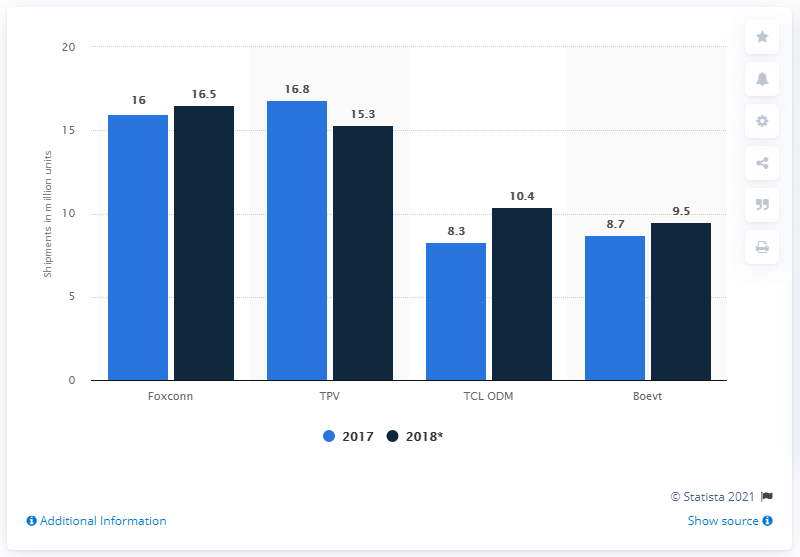Indicate a few pertinent items in this graphic. According to sources, it is expected that Foxconn will be the ODM that ships the most LCD TVs in 2018. In 2018, Foxconn shipped a total of 16.5 LCD TVs. 